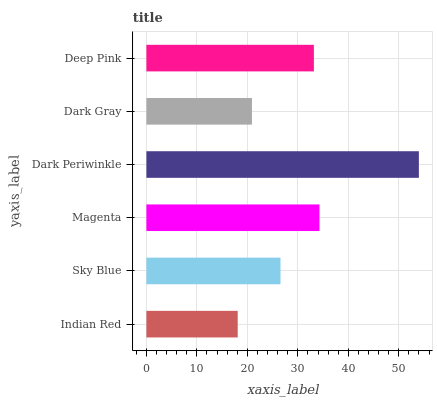Is Indian Red the minimum?
Answer yes or no. Yes. Is Dark Periwinkle the maximum?
Answer yes or no. Yes. Is Sky Blue the minimum?
Answer yes or no. No. Is Sky Blue the maximum?
Answer yes or no. No. Is Sky Blue greater than Indian Red?
Answer yes or no. Yes. Is Indian Red less than Sky Blue?
Answer yes or no. Yes. Is Indian Red greater than Sky Blue?
Answer yes or no. No. Is Sky Blue less than Indian Red?
Answer yes or no. No. Is Deep Pink the high median?
Answer yes or no. Yes. Is Sky Blue the low median?
Answer yes or no. Yes. Is Sky Blue the high median?
Answer yes or no. No. Is Dark Gray the low median?
Answer yes or no. No. 